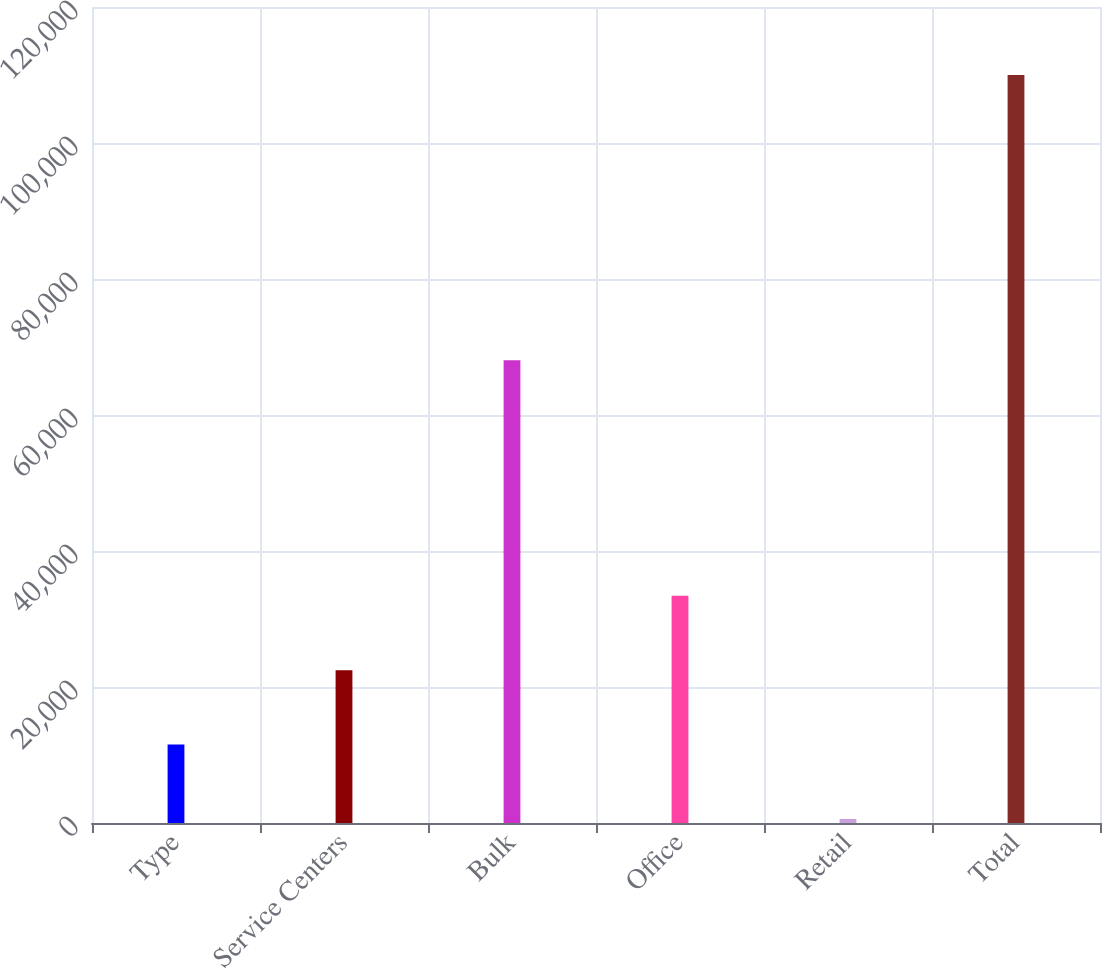Convert chart. <chart><loc_0><loc_0><loc_500><loc_500><bar_chart><fcel>Type<fcel>Service Centers<fcel>Bulk<fcel>Office<fcel>Retail<fcel>Total<nl><fcel>11535.1<fcel>22474.2<fcel>68068<fcel>33413.3<fcel>596<fcel>109987<nl></chart> 